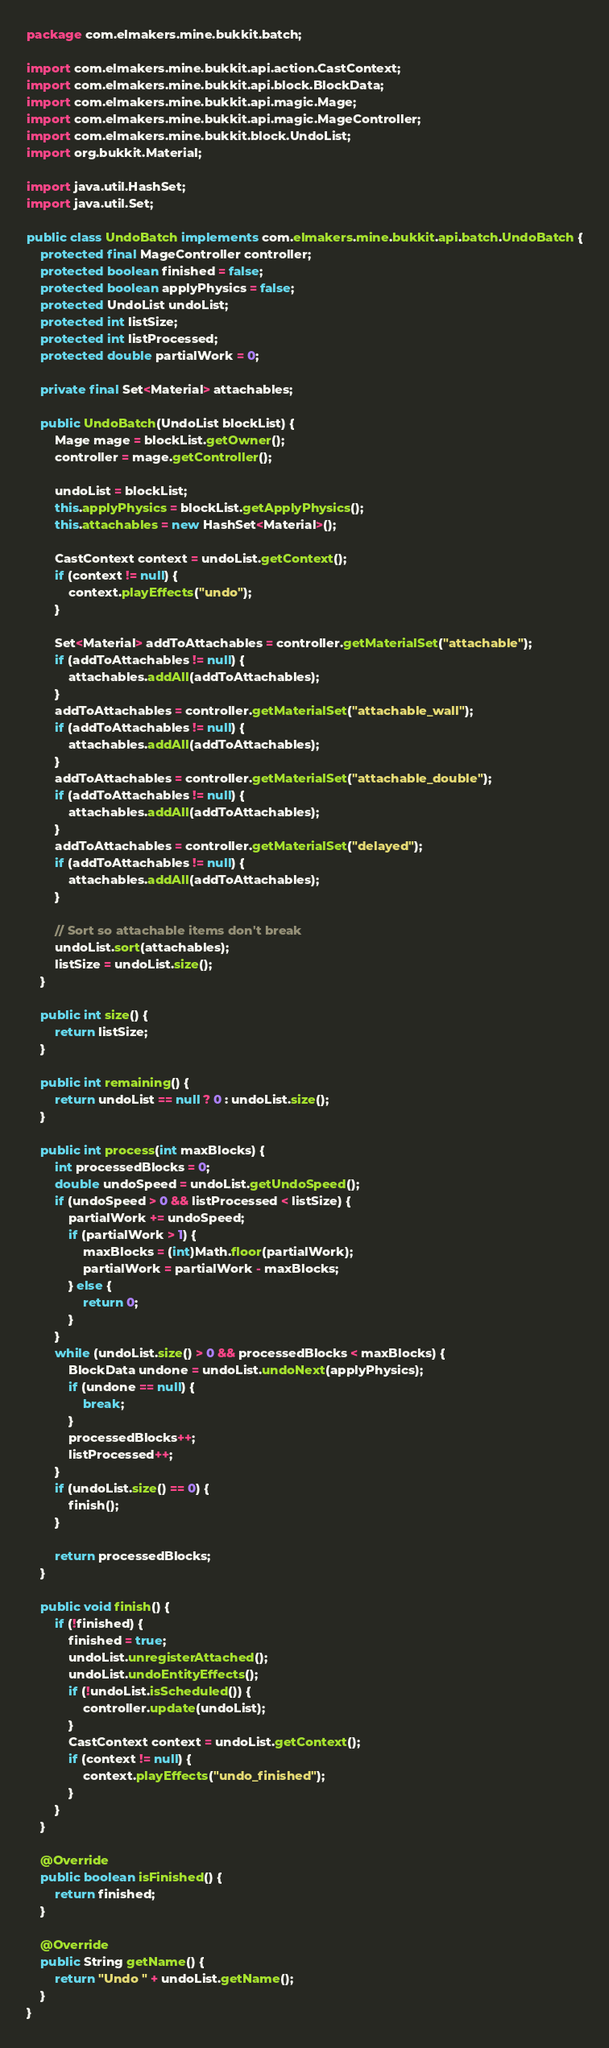<code> <loc_0><loc_0><loc_500><loc_500><_Java_>package com.elmakers.mine.bukkit.batch;

import com.elmakers.mine.bukkit.api.action.CastContext;
import com.elmakers.mine.bukkit.api.block.BlockData;
import com.elmakers.mine.bukkit.api.magic.Mage;
import com.elmakers.mine.bukkit.api.magic.MageController;
import com.elmakers.mine.bukkit.block.UndoList;
import org.bukkit.Material;

import java.util.HashSet;
import java.util.Set;

public class UndoBatch implements com.elmakers.mine.bukkit.api.batch.UndoBatch {
    protected final MageController controller;
    protected boolean finished = false;
    protected boolean applyPhysics = false;
    protected UndoList undoList;
    protected int listSize;
    protected int listProcessed;
    protected double partialWork = 0;

    private final Set<Material> attachables;

    public UndoBatch(UndoList blockList) {
        Mage mage = blockList.getOwner();
        controller = mage.getController();

        undoList = blockList;
        this.applyPhysics = blockList.getApplyPhysics();
        this.attachables = new HashSet<Material>();

        CastContext context = undoList.getContext();
        if (context != null) {
            context.playEffects("undo");
        }

        Set<Material> addToAttachables = controller.getMaterialSet("attachable");
        if (addToAttachables != null) {
            attachables.addAll(addToAttachables);
        }
        addToAttachables = controller.getMaterialSet("attachable_wall");
        if (addToAttachables != null) {
            attachables.addAll(addToAttachables);
        }
        addToAttachables = controller.getMaterialSet("attachable_double");
        if (addToAttachables != null) {
            attachables.addAll(addToAttachables);
        }
        addToAttachables = controller.getMaterialSet("delayed");
        if (addToAttachables != null) {
            attachables.addAll(addToAttachables);
        }

        // Sort so attachable items don't break
        undoList.sort(attachables);
        listSize = undoList.size();
    }

    public int size() {
        return listSize;
    }

    public int remaining() {
        return undoList == null ? 0 : undoList.size();
    }

    public int process(int maxBlocks) {
        int processedBlocks = 0;
        double undoSpeed = undoList.getUndoSpeed();
        if (undoSpeed > 0 && listProcessed < listSize) {
            partialWork += undoSpeed;
            if (partialWork > 1) {
                maxBlocks = (int)Math.floor(partialWork);
                partialWork = partialWork - maxBlocks;
            } else {
                return 0;
            }
        }
        while (undoList.size() > 0 && processedBlocks < maxBlocks) {
            BlockData undone = undoList.undoNext(applyPhysics);
            if (undone == null) {
                break;
            }
            processedBlocks++;
            listProcessed++;
        }
        if (undoList.size() == 0) {
            finish();
        }

        return processedBlocks;
    }

    public void finish() {
        if (!finished) {
            finished = true;
            undoList.unregisterAttached();
            undoList.undoEntityEffects();
            if (!undoList.isScheduled()) {
                controller.update(undoList);
            }
            CastContext context = undoList.getContext();
            if (context != null) {
                context.playEffects("undo_finished");
            }
        }
    }

    @Override
    public boolean isFinished() {
        return finished;
    }

    @Override
    public String getName() {
        return "Undo " + undoList.getName();
    }
}
</code> 